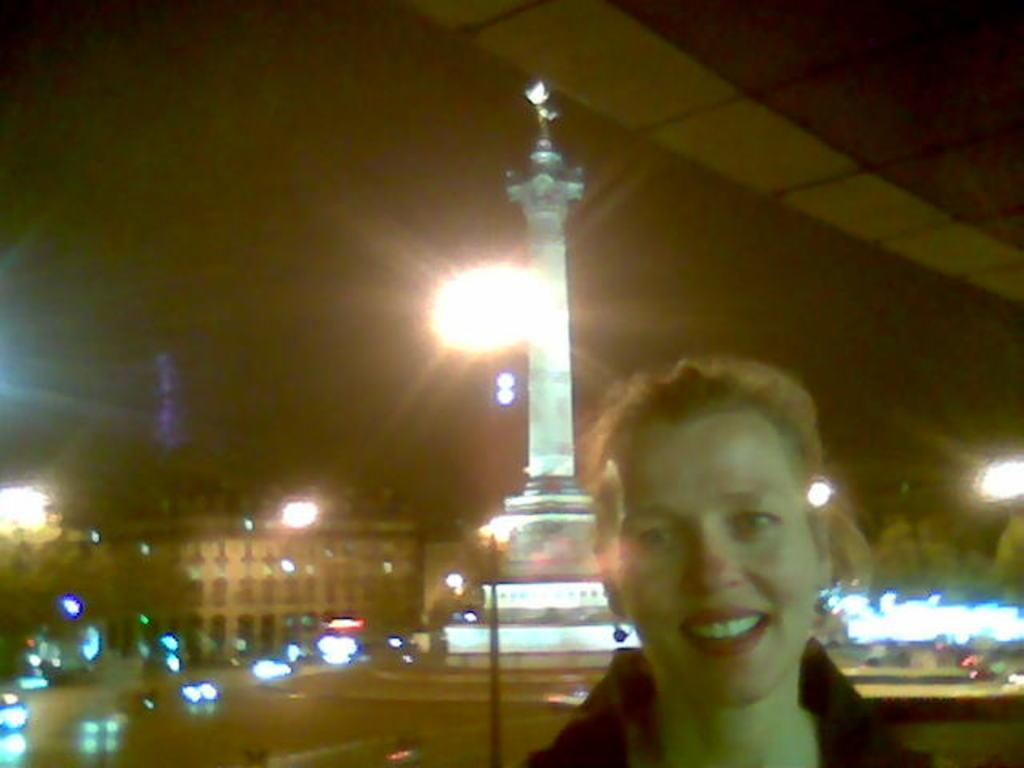What is the main subject of the image? There is a person in the image. What can be seen behind the person? There is a white color statue behind the person. What type of structures are visible in the image? There are buildings visible in the image. What kind of illumination is present in the image? There are lights present in the image. What type of insurance policy does the person in the image have? There is no information about insurance policies in the image, as it focuses on the person, the statue, buildings, and lights. 